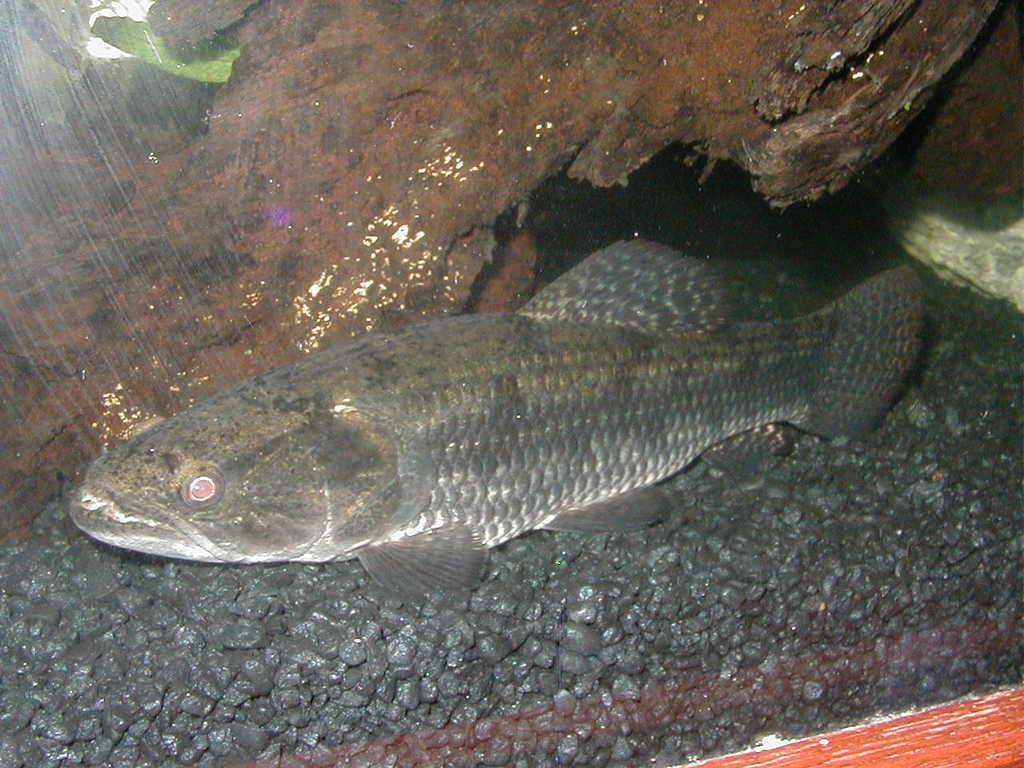How would you summarize this image in a sentence or two? In this image we can see a fish in the water. We can also see a rock. 